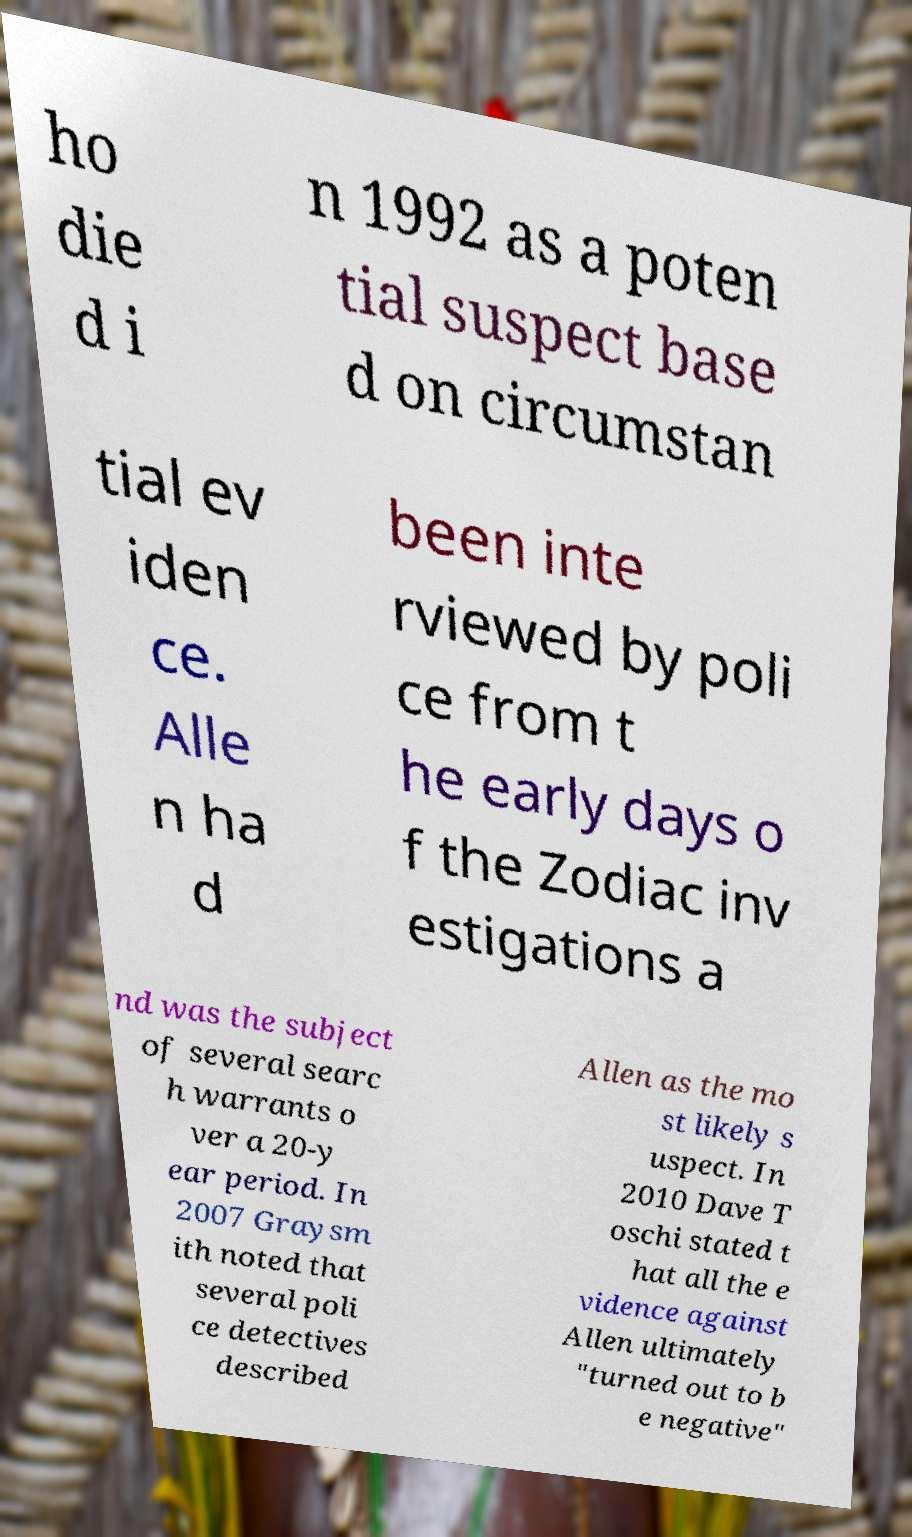Can you accurately transcribe the text from the provided image for me? ho die d i n 1992 as a poten tial suspect base d on circumstan tial ev iden ce. Alle n ha d been inte rviewed by poli ce from t he early days o f the Zodiac inv estigations a nd was the subject of several searc h warrants o ver a 20-y ear period. In 2007 Graysm ith noted that several poli ce detectives described Allen as the mo st likely s uspect. In 2010 Dave T oschi stated t hat all the e vidence against Allen ultimately "turned out to b e negative" 